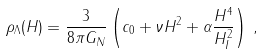<formula> <loc_0><loc_0><loc_500><loc_500>\rho _ { \Lambda } ( H ) = \frac { 3 } { 8 \pi G _ { N } } \left ( c _ { 0 } + \nu H ^ { 2 } + \alpha \frac { H ^ { 4 } } { H _ { I } ^ { 2 } } \right ) \, ,</formula> 